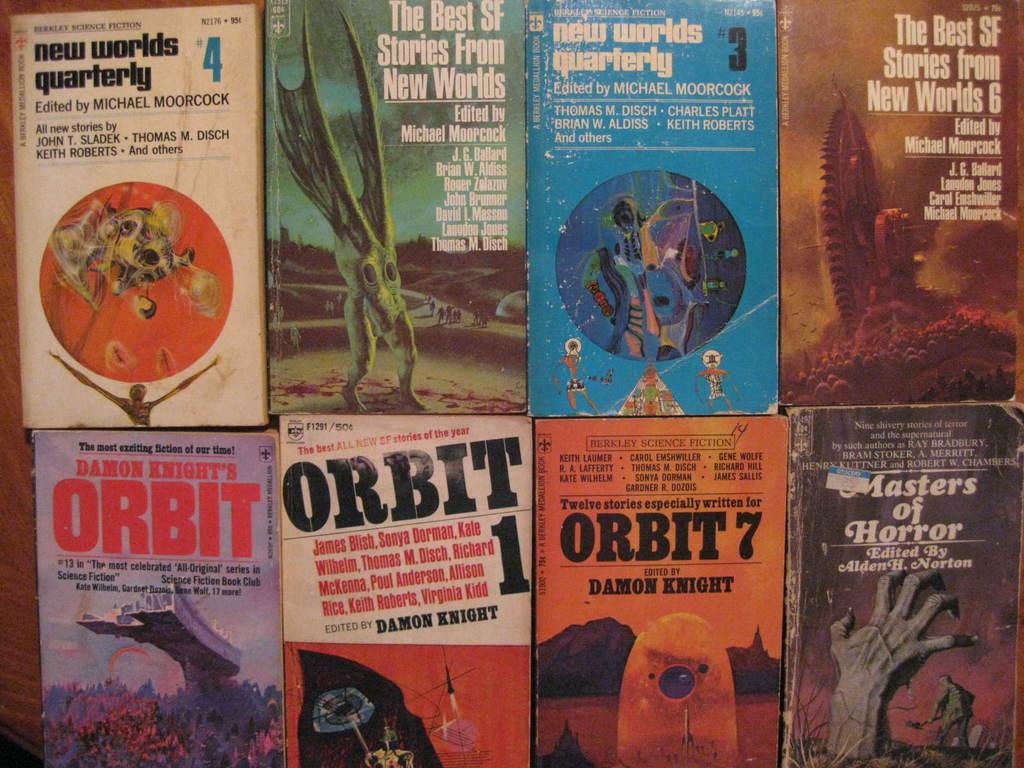<image>
Provide a brief description of the given image. Several collections of science fiction stories including both the New Worlds and Orbit series. 